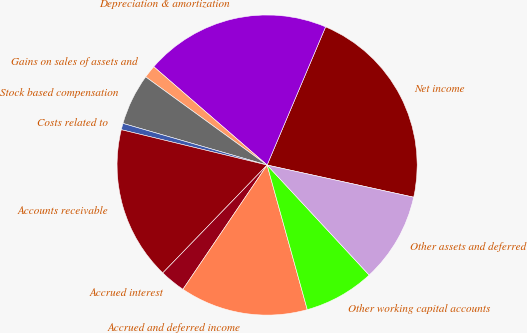Convert chart. <chart><loc_0><loc_0><loc_500><loc_500><pie_chart><fcel>Net income<fcel>Depreciation & amortization<fcel>Gains on sales of assets and<fcel>Stock based compensation<fcel>Costs related to<fcel>Accounts receivable<fcel>Accrued interest<fcel>Accrued and deferred income<fcel>Other working capital accounts<fcel>Other assets and deferred<nl><fcel>22.07%<fcel>20.0%<fcel>1.38%<fcel>5.52%<fcel>0.69%<fcel>16.55%<fcel>2.76%<fcel>13.79%<fcel>7.59%<fcel>9.66%<nl></chart> 